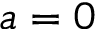<formula> <loc_0><loc_0><loc_500><loc_500>a = 0</formula> 